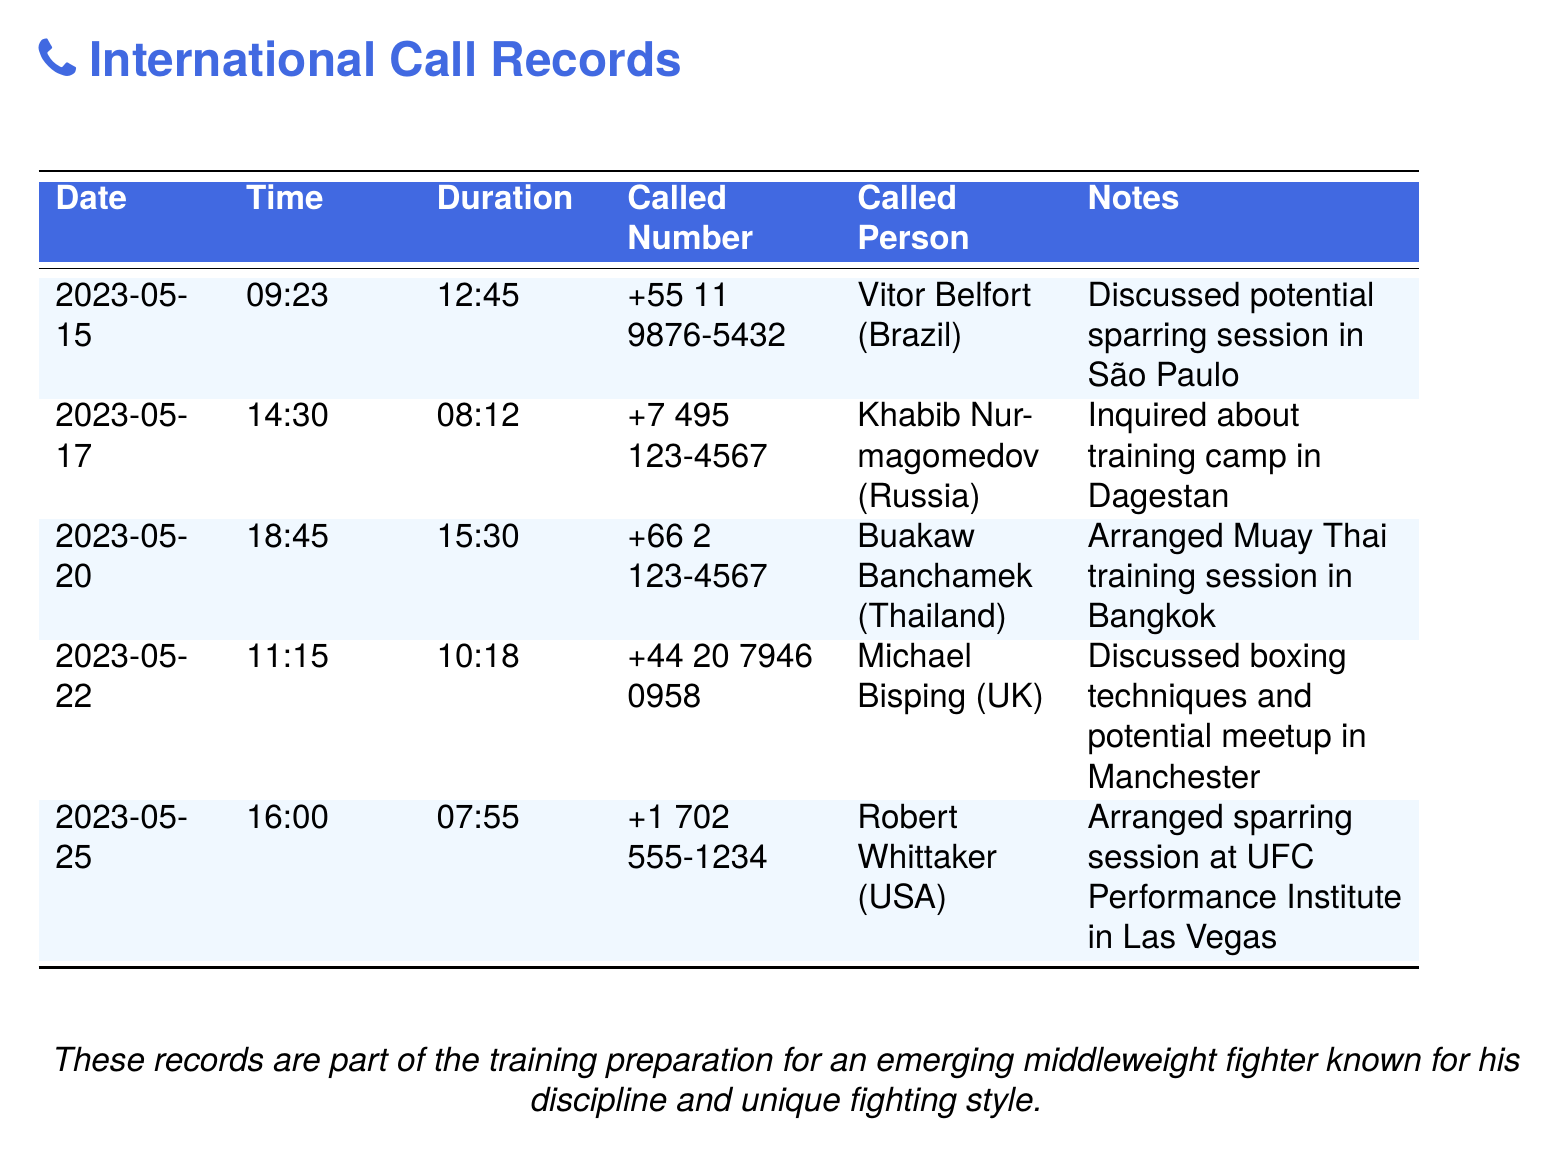What is the date of the call to Khabib Nurmagomedov? The date of the call can be found in the record for Khabib Nurmagomedov, which is listed as 2023-05-17.
Answer: 2023-05-17 Who was called on May 25, 2023? On May 25, 2023, the call was made to Robert Whittaker, as indicated in the record.
Answer: Robert Whittaker What is the duration of the call to Michael Bisping? The duration of the call can be found in the record for Michael Bisping, which is listed as 10:18.
Answer: 10:18 What type of training session was arranged with Buakaw Banchamek? The type of training session can be deduced from the notes accompanying the record for Buakaw Banchamek, which mentions a Muay Thai training session.
Answer: Muay Thai training session How many sparring partners are mentioned in the document? The document mentions five different sparring partners, which can be counted from the rows in the table.
Answer: Five What country is Michael Bisping from? The country can be found in the record associated with Michael Bisping, which lists the UK.
Answer: UK Which call had the longest duration? By comparing the durations in the document, the call to Buakaw Banchamek has the longest duration at 15:30.
Answer: 15:30 What was discussed in the call to Vitor Belfort? The notes for the call to Vitor Belfort indicate that the discussion was about a potential sparring session.
Answer: Potential sparring session What was the time of the call to Robert Whittaker? The specific time of the call to Robert Whittaker can be extracted from the record as 16:00.
Answer: 16:00 